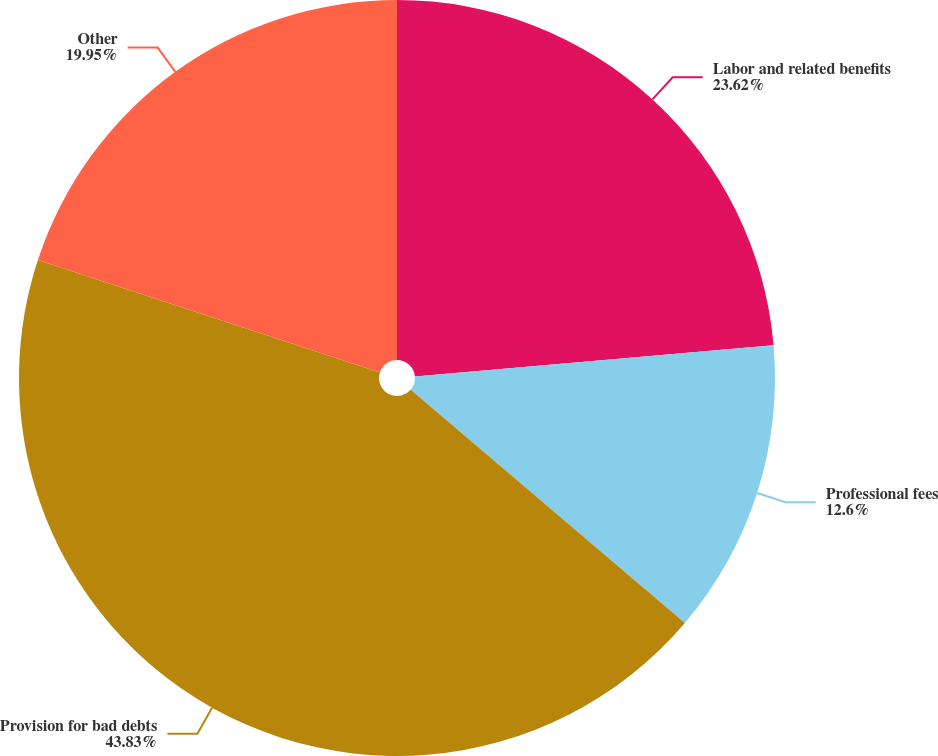<chart> <loc_0><loc_0><loc_500><loc_500><pie_chart><fcel>Labor and related benefits<fcel>Professional fees<fcel>Provision for bad debts<fcel>Other<nl><fcel>23.62%<fcel>12.6%<fcel>43.83%<fcel>19.95%<nl></chart> 